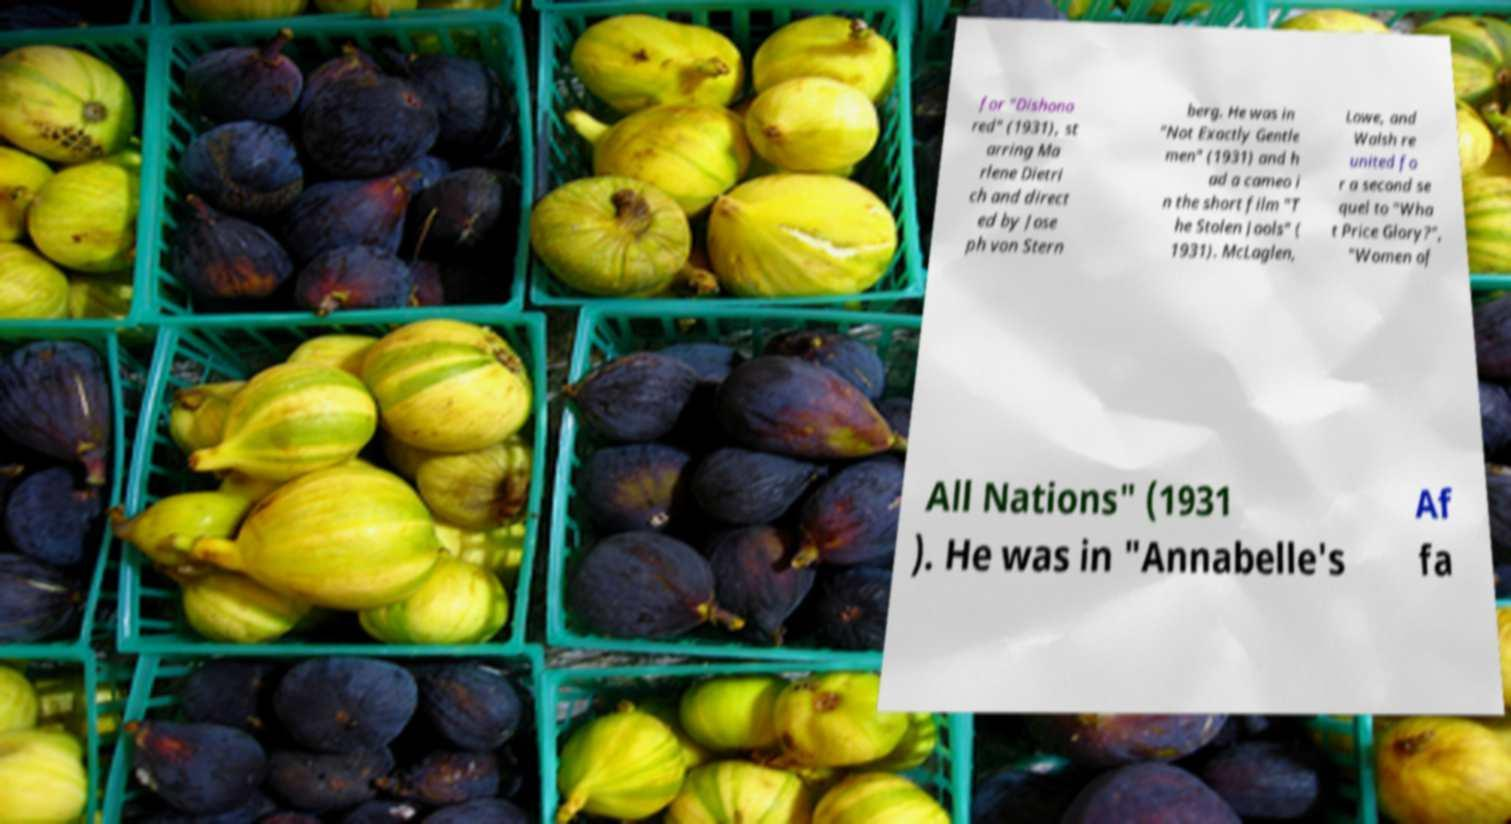Please identify and transcribe the text found in this image. for "Dishono red" (1931), st arring Ma rlene Dietri ch and direct ed by Jose ph von Stern berg. He was in "Not Exactly Gentle men" (1931) and h ad a cameo i n the short film "T he Stolen Jools" ( 1931). McLaglen, Lowe, and Walsh re united fo r a second se quel to "Wha t Price Glory?", "Women of All Nations" (1931 ). He was in "Annabelle's Af fa 